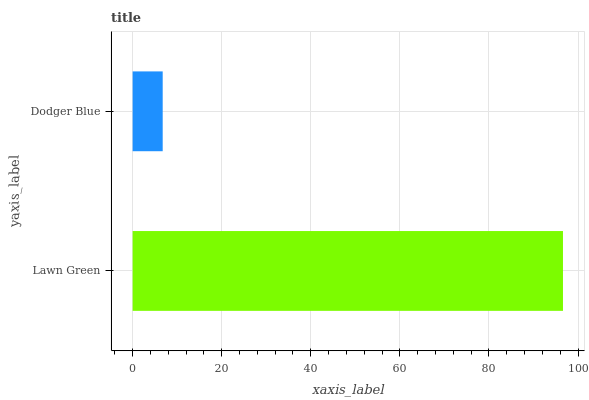Is Dodger Blue the minimum?
Answer yes or no. Yes. Is Lawn Green the maximum?
Answer yes or no. Yes. Is Dodger Blue the maximum?
Answer yes or no. No. Is Lawn Green greater than Dodger Blue?
Answer yes or no. Yes. Is Dodger Blue less than Lawn Green?
Answer yes or no. Yes. Is Dodger Blue greater than Lawn Green?
Answer yes or no. No. Is Lawn Green less than Dodger Blue?
Answer yes or no. No. Is Lawn Green the high median?
Answer yes or no. Yes. Is Dodger Blue the low median?
Answer yes or no. Yes. Is Dodger Blue the high median?
Answer yes or no. No. Is Lawn Green the low median?
Answer yes or no. No. 